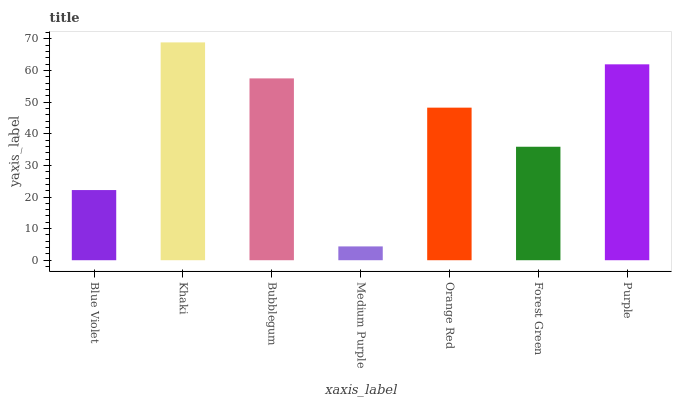Is Medium Purple the minimum?
Answer yes or no. Yes. Is Khaki the maximum?
Answer yes or no. Yes. Is Bubblegum the minimum?
Answer yes or no. No. Is Bubblegum the maximum?
Answer yes or no. No. Is Khaki greater than Bubblegum?
Answer yes or no. Yes. Is Bubblegum less than Khaki?
Answer yes or no. Yes. Is Bubblegum greater than Khaki?
Answer yes or no. No. Is Khaki less than Bubblegum?
Answer yes or no. No. Is Orange Red the high median?
Answer yes or no. Yes. Is Orange Red the low median?
Answer yes or no. Yes. Is Blue Violet the high median?
Answer yes or no. No. Is Khaki the low median?
Answer yes or no. No. 